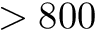<formula> <loc_0><loc_0><loc_500><loc_500>> 8 0 0</formula> 